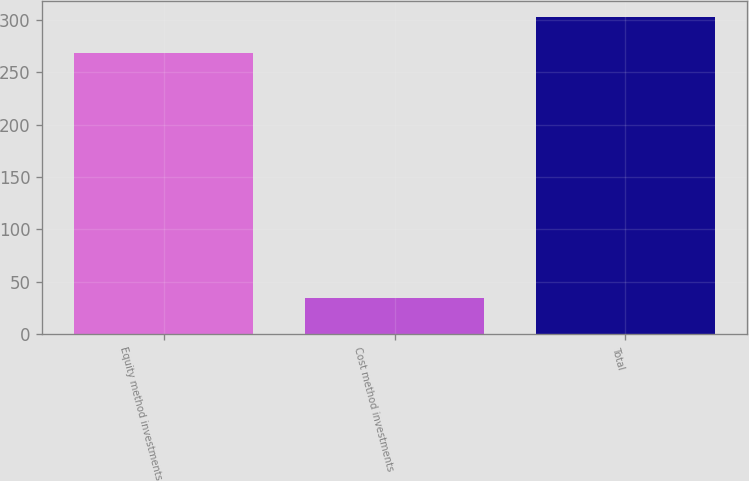Convert chart to OTSL. <chart><loc_0><loc_0><loc_500><loc_500><bar_chart><fcel>Equity method investments<fcel>Cost method investments<fcel>Total<nl><fcel>267.9<fcel>34.7<fcel>302.6<nl></chart> 